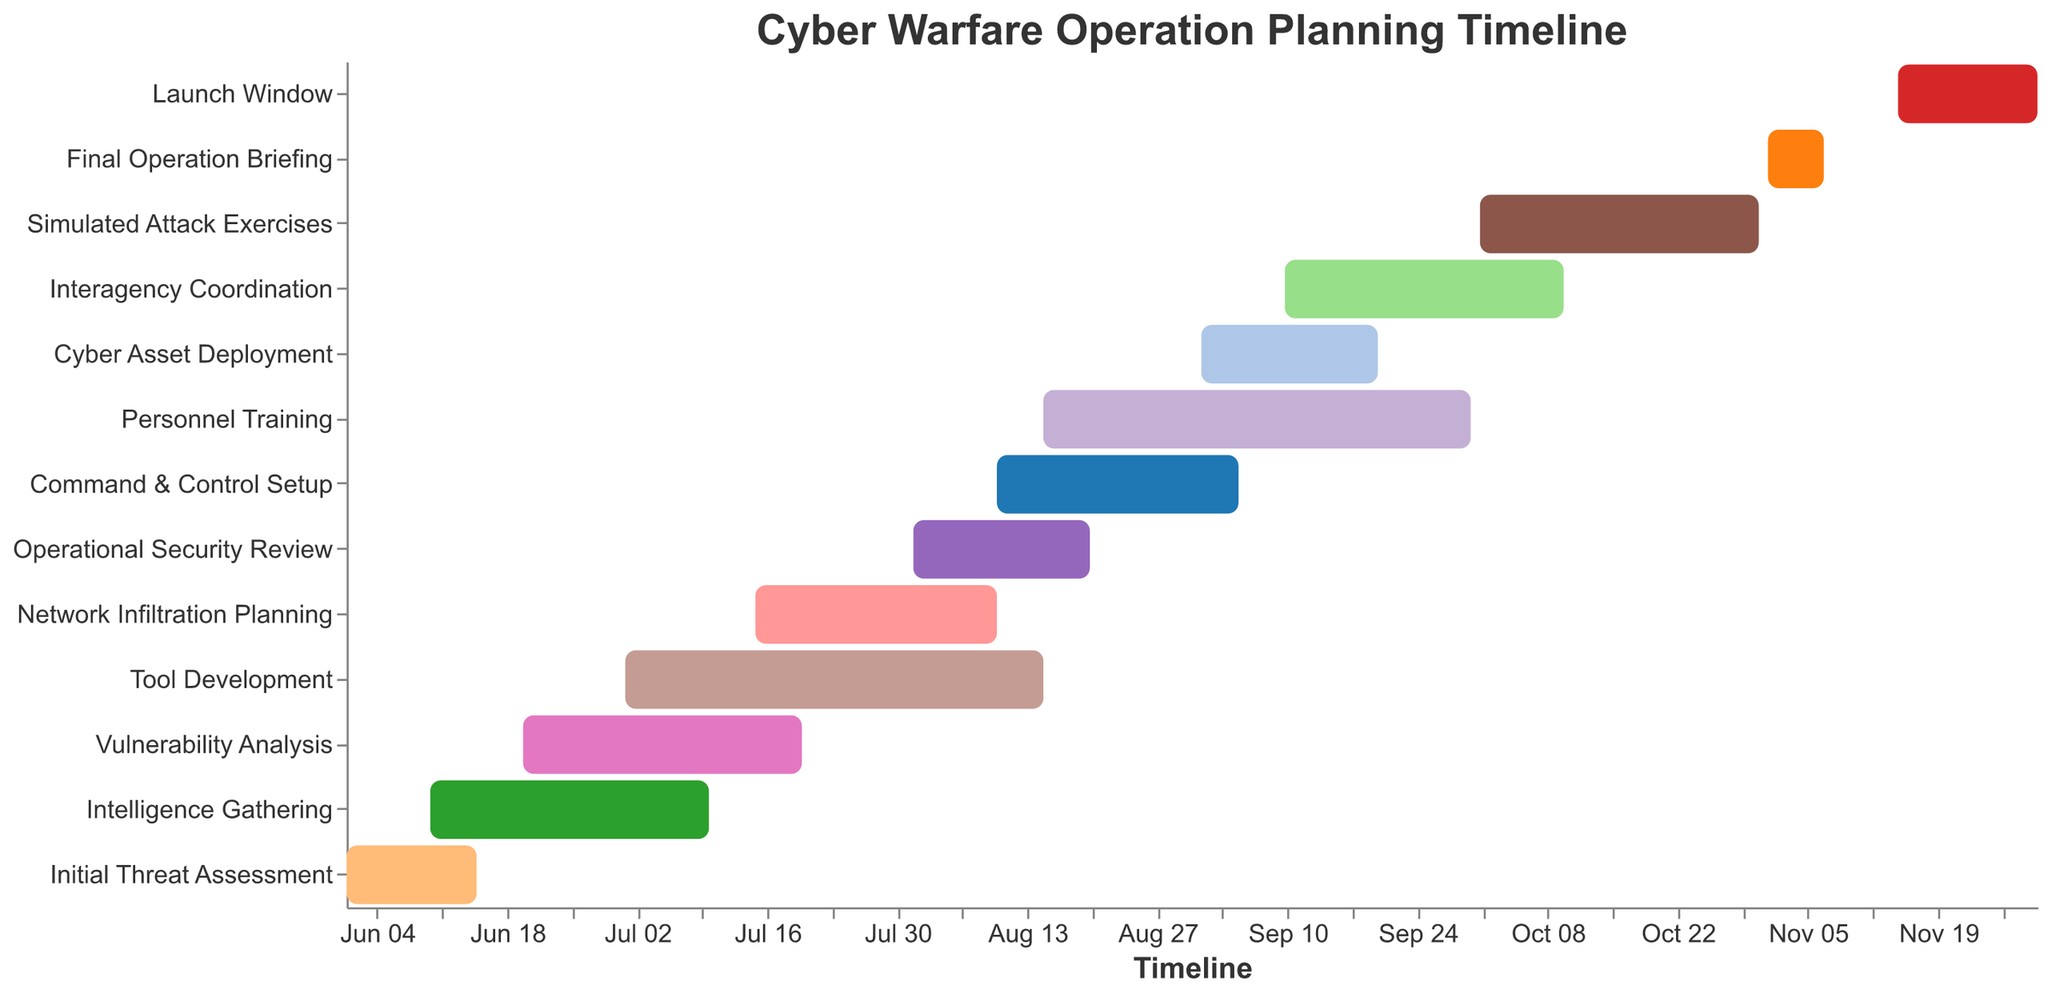What is the title of the Gantt Chart? The title of the Gantt Chart is displayed at the top in the figure. It reads "Cyber Warfare Operation Planning Timeline".
Answer: Cyber Warfare Operation Planning Timeline Which task has the longest duration? To determine the longest duration, compare the start and end dates of each task. Personnel Training runs from August 15 to September 30, making it the longest task.
Answer: Personnel Training How many tasks are scheduled to start in August 2023? By looking at the timeline axis and start dates, we can see that Tool Development, Operational Security Review, Command & Control Setup, and Personnel Training start in August.
Answer: Four Which tasks overlap with Intelligence Gathering? Look for tasks whose start and end dates fall within June 10 to July 10. Vulnerability Analysis and Tool Development overlap with Intelligence Gathering.
Answer: Vulnerability Analysis, Tool Development What tasks are conducted after Cyber Asset Deployment starts? Cyber Asset Deployment starts on September 1. Tasks starting after this date are Interagency Coordination, Simulated Attack Exercises, Final Operation Briefing, and Launch Window.
Answer: Interagency Coordination, Simulated Attack Exercises, Final Operation Briefing, Launch Window What is the duration of the Simulated Attack Exercises task? Simulated Attack Exercises starts on October 1 and ends on October 31. The duration is the difference between the start and end dates.
Answer: 31 days Which task ends the earliest? By comparing the end dates of all tasks, Initial Threat Assessment ends first on June 15.
Answer: Initial Threat Assessment How many tasks have start dates in July 2023? Looking at the timeline axis and start dates, Vulnerability Analysis, Tool Development, and Network Infiltration Planning start in July.
Answer: Three Which tasks are shorter than 20 days? Compare the duration of tasks. Initial Threat Assessment (14 days), Network Infiltration Planning (26 days, but only events shorter than 20 days) is shorter.
Answer: Initial Threat Assessment What is the total time span from the start of the first task to the end of the last task? The earliest start date is June 1 (Initial Threat Assessment) and the latest end date is November 30 (Launch Window). Calculate the time span between these two dates.
Answer: 183 days 